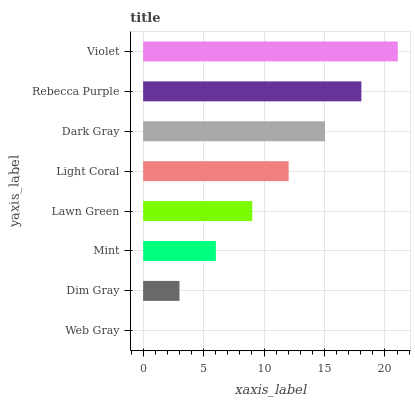Is Web Gray the minimum?
Answer yes or no. Yes. Is Violet the maximum?
Answer yes or no. Yes. Is Dim Gray the minimum?
Answer yes or no. No. Is Dim Gray the maximum?
Answer yes or no. No. Is Dim Gray greater than Web Gray?
Answer yes or no. Yes. Is Web Gray less than Dim Gray?
Answer yes or no. Yes. Is Web Gray greater than Dim Gray?
Answer yes or no. No. Is Dim Gray less than Web Gray?
Answer yes or no. No. Is Light Coral the high median?
Answer yes or no. Yes. Is Lawn Green the low median?
Answer yes or no. Yes. Is Web Gray the high median?
Answer yes or no. No. Is Web Gray the low median?
Answer yes or no. No. 